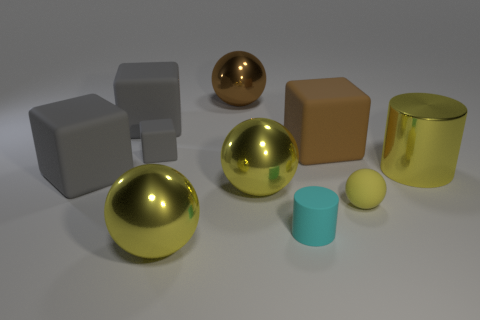What size is the gray matte object in front of the big metal cylinder?
Ensure brevity in your answer.  Large. There is a object left of the big gray cube that is behind the big rubber object in front of the big shiny cylinder; what is it made of?
Make the answer very short. Rubber. Does the small cyan object have the same shape as the small gray object?
Your response must be concise. No. What number of shiny things are either tiny cyan things or large gray cubes?
Your answer should be compact. 0. How many large yellow metallic objects are there?
Provide a succinct answer. 3. The matte cylinder that is the same size as the yellow matte sphere is what color?
Offer a terse response. Cyan. Is the cyan thing the same size as the brown cube?
Make the answer very short. No. The matte thing that is the same color as the big cylinder is what shape?
Your answer should be compact. Sphere. There is a cyan object; is its size the same as the yellow metal thing to the right of the brown matte cube?
Your answer should be compact. No. The thing that is to the right of the brown matte object and behind the yellow matte thing is what color?
Make the answer very short. Yellow. 